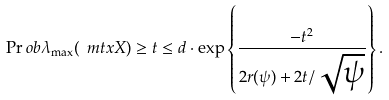Convert formula to latex. <formula><loc_0><loc_0><loc_500><loc_500>\Pr o b { \lambda _ { \max } ( \ m t x { X } ) \geq t } \leq d \cdot \exp \left \{ \frac { - t ^ { 2 } } { 2 r ( \psi ) + 2 t / \sqrt { \psi } } \right \} .</formula> 